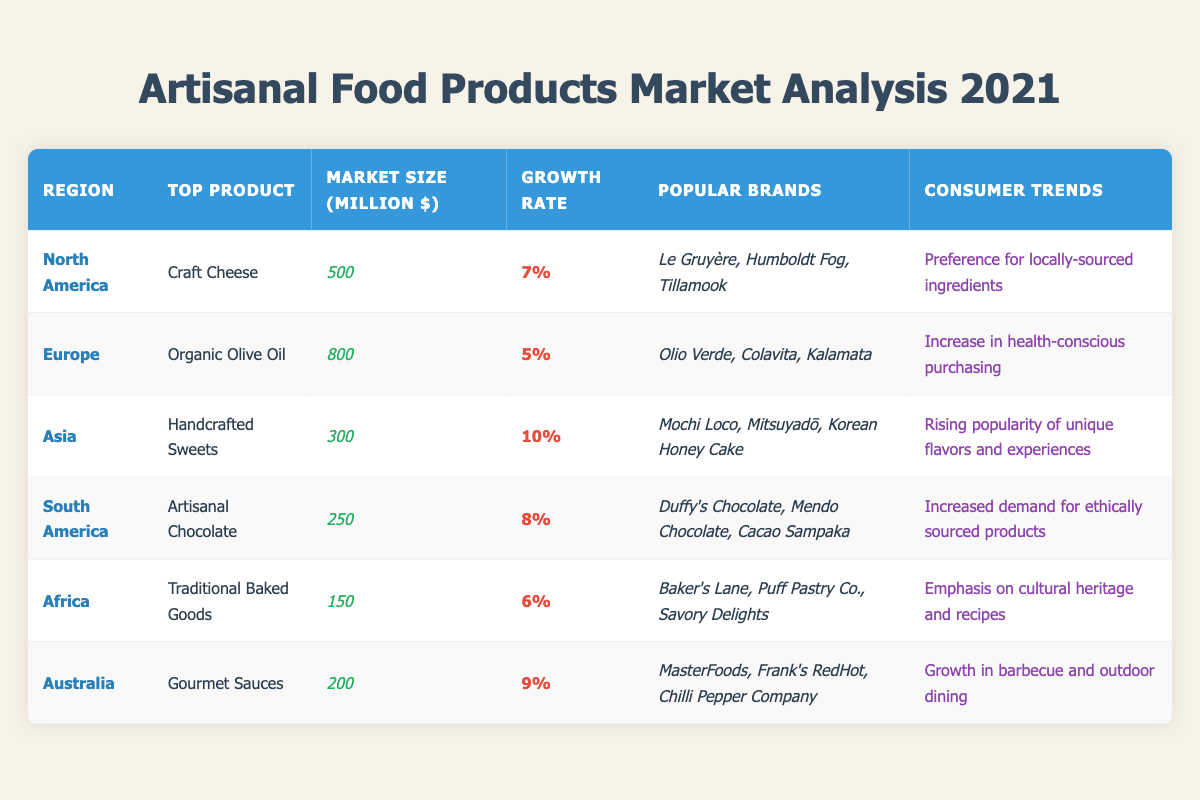What is the top artisanal food product in North America? The table shows that the top product in North America is "Craft Cheese".
Answer: Craft Cheese Which region has the largest market size for artisanal food products? According to the table, Europe has the largest market size at 800 million dollars.
Answer: Europe What is the growth rate of artisanal chocolate in South America? The growth rate listed for artisanal chocolate in South America is 8%.
Answer: 8% How many regions have a market size greater than 250 million dollars? In the table, North America (500 million) and Europe (800 million) are the only regions over 250 million, which makes it 2 regions.
Answer: 2 Is the growth rate of handcrafted sweets in Asia higher than that of organic olive oil in Europe? The growth rate for handcrafted sweets in Asia is 10%, while it is 5% for organic olive oil in Europe, confirming that it is higher.
Answer: True What is the total market size for all regions combined? Adding the market sizes gives (500 + 800 + 300 + 250 + 150 + 200) = 2200 million dollars for all regions combined.
Answer: 2200 million dollars Which region has a consumer trend focusing on health consciousness? The table states that Europe has a consumer trend of "Increase in health-conscious purchasing".
Answer: Europe What is the difference in market size between North America and Africa? North America has a market size of 500 million and Africa 150 million, so the difference is 500 - 150 = 350 million dollars.
Answer: 350 million dollars How does the market size of Asia compare to that of Australia? Asia has a market size of 300 million, while Australia has 200 million; since 300 is greater than 200, Asia's market size is larger.
Answer: Asia has a larger market size Which region has the highest growth rate, and what is that rate? The region with the highest growth rate is Asia at 10%.
Answer: 10% 